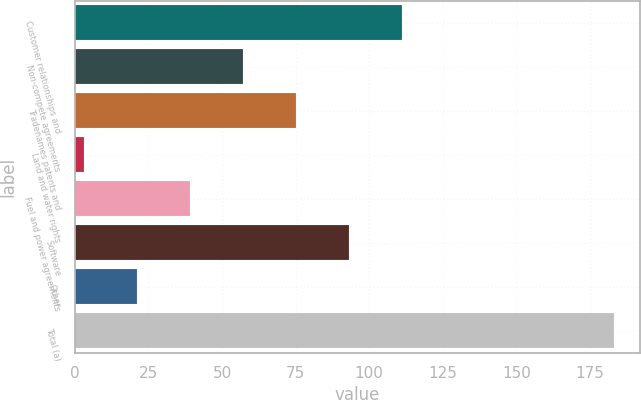Convert chart to OTSL. <chart><loc_0><loc_0><loc_500><loc_500><bar_chart><fcel>Customer relationships and<fcel>Non-compete agreements<fcel>Tradenames patents and<fcel>Land and water rights<fcel>Fuel and power agreements<fcel>Software<fcel>Other<fcel>Total (a)<nl><fcel>111<fcel>57<fcel>75<fcel>3<fcel>39<fcel>93<fcel>21<fcel>183<nl></chart> 